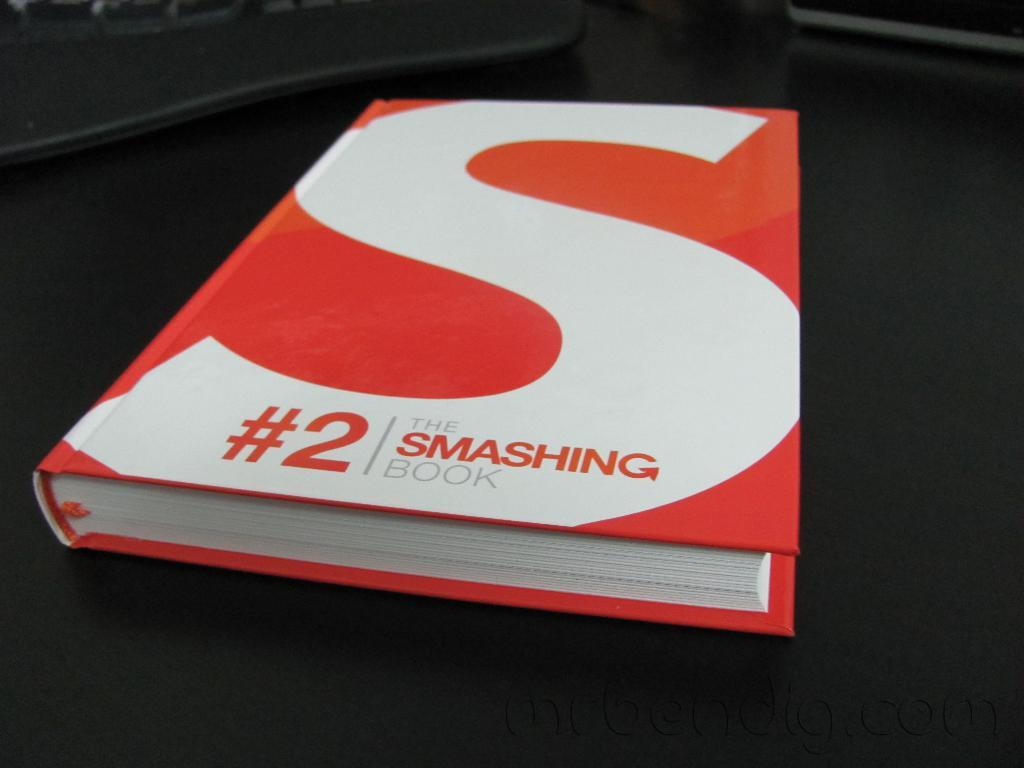Provide a one-sentence caption for the provided image. A red and white book titled" #2 The Smashing Book.". 